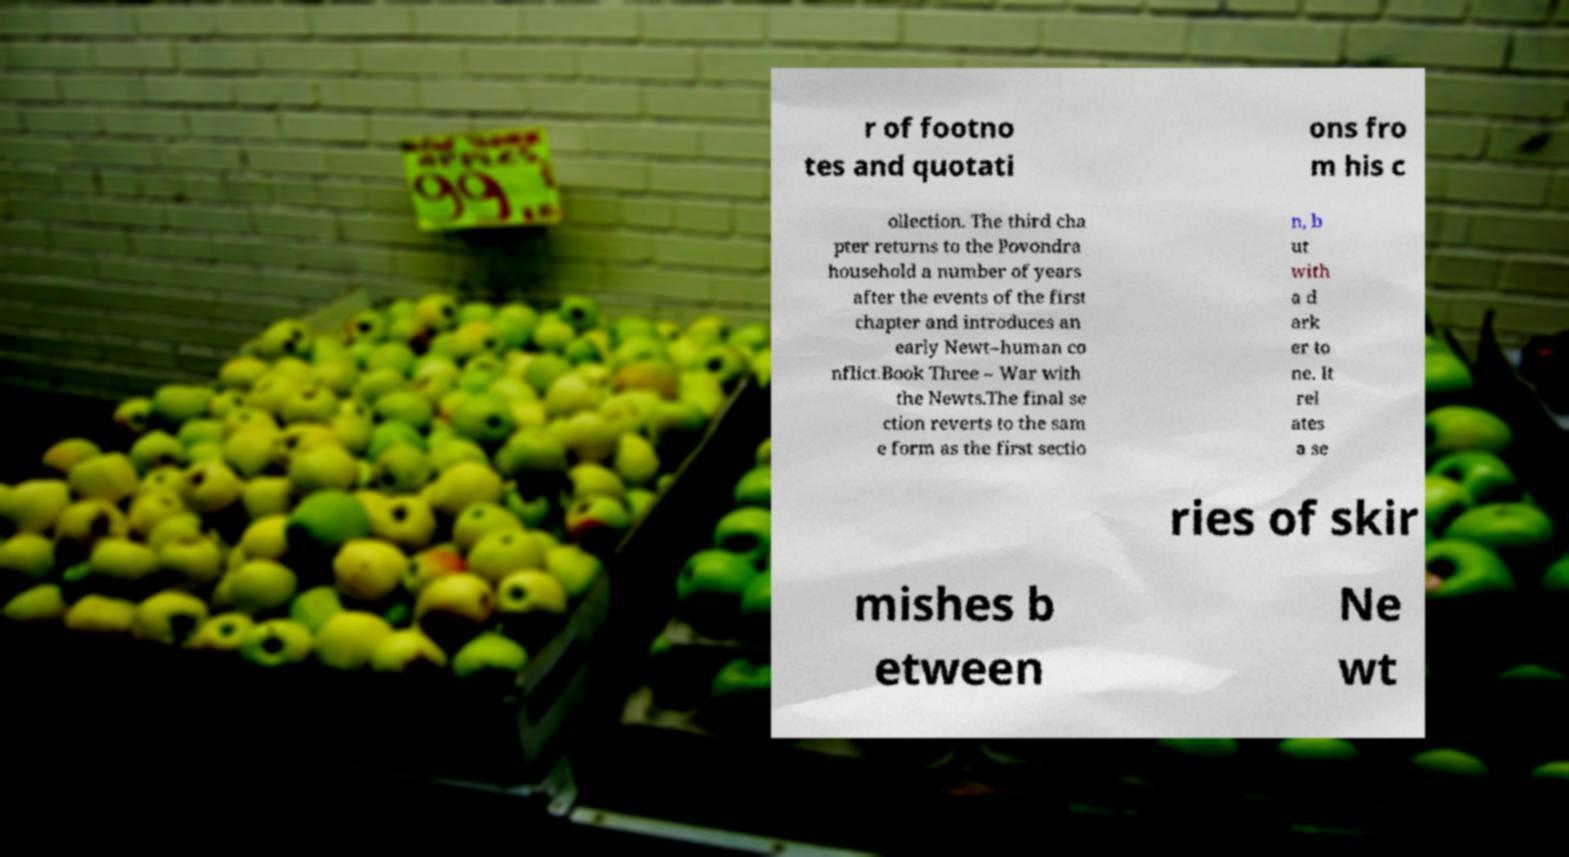Can you accurately transcribe the text from the provided image for me? r of footno tes and quotati ons fro m his c ollection. The third cha pter returns to the Povondra household a number of years after the events of the first chapter and introduces an early Newt–human co nflict.Book Three – War with the Newts.The final se ction reverts to the sam e form as the first sectio n, b ut with a d ark er to ne. It rel ates a se ries of skir mishes b etween Ne wt 